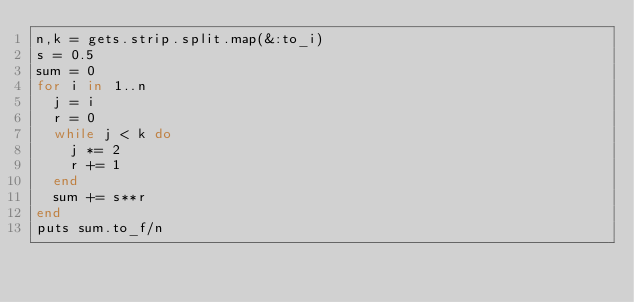Convert code to text. <code><loc_0><loc_0><loc_500><loc_500><_Ruby_>n,k = gets.strip.split.map(&:to_i)
s = 0.5
sum = 0
for i in 1..n
  j = i
  r = 0
  while j < k do
    j *= 2
    r += 1
  end
  sum += s**r
end
puts sum.to_f/n</code> 